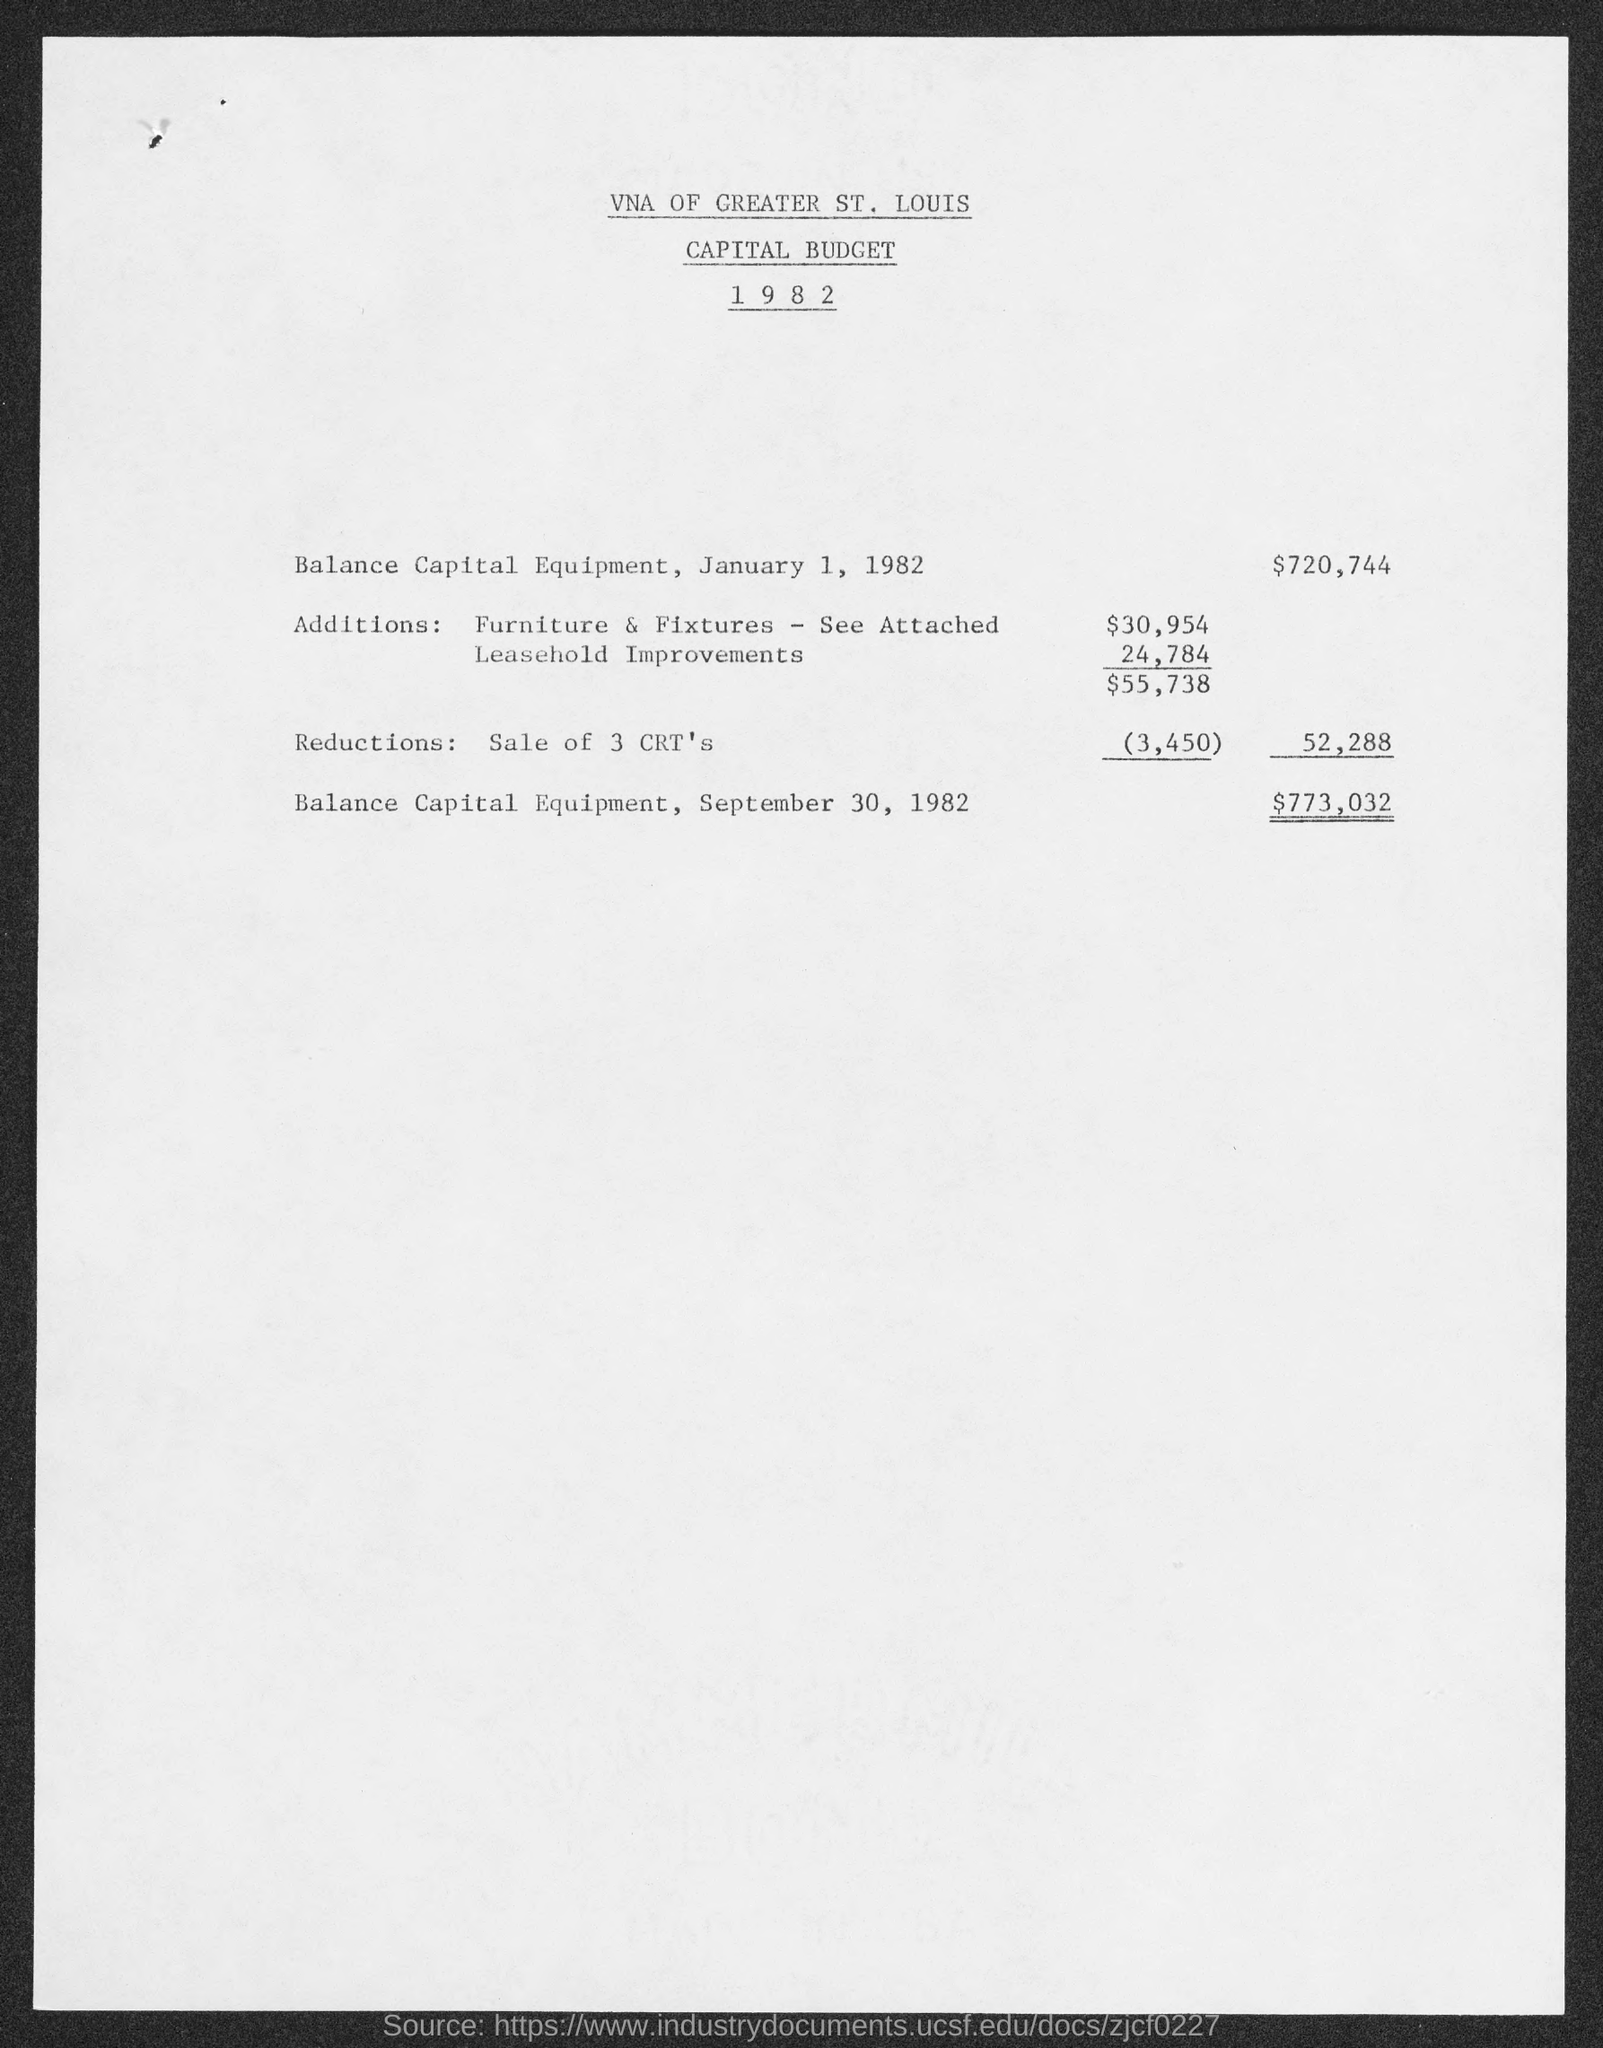Which association's Capital Budget 1982 is given here?
Your response must be concise. VNA OF GREATER ST. LOUIS. What is the Balance Capital Equipment on January 1, 1982?
Give a very brief answer. $720,744. What is the Balance Capital Equipment on September 30, 1982?
Provide a succinct answer. $773,032. 